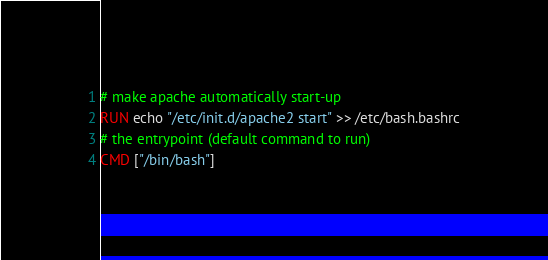Convert code to text. <code><loc_0><loc_0><loc_500><loc_500><_Dockerfile_># make apache automatically start-up
RUN echo "/etc/init.d/apache2 start" >> /etc/bash.bashrc
# the entrypoint (default command to run)
CMD ["/bin/bash"]</code> 